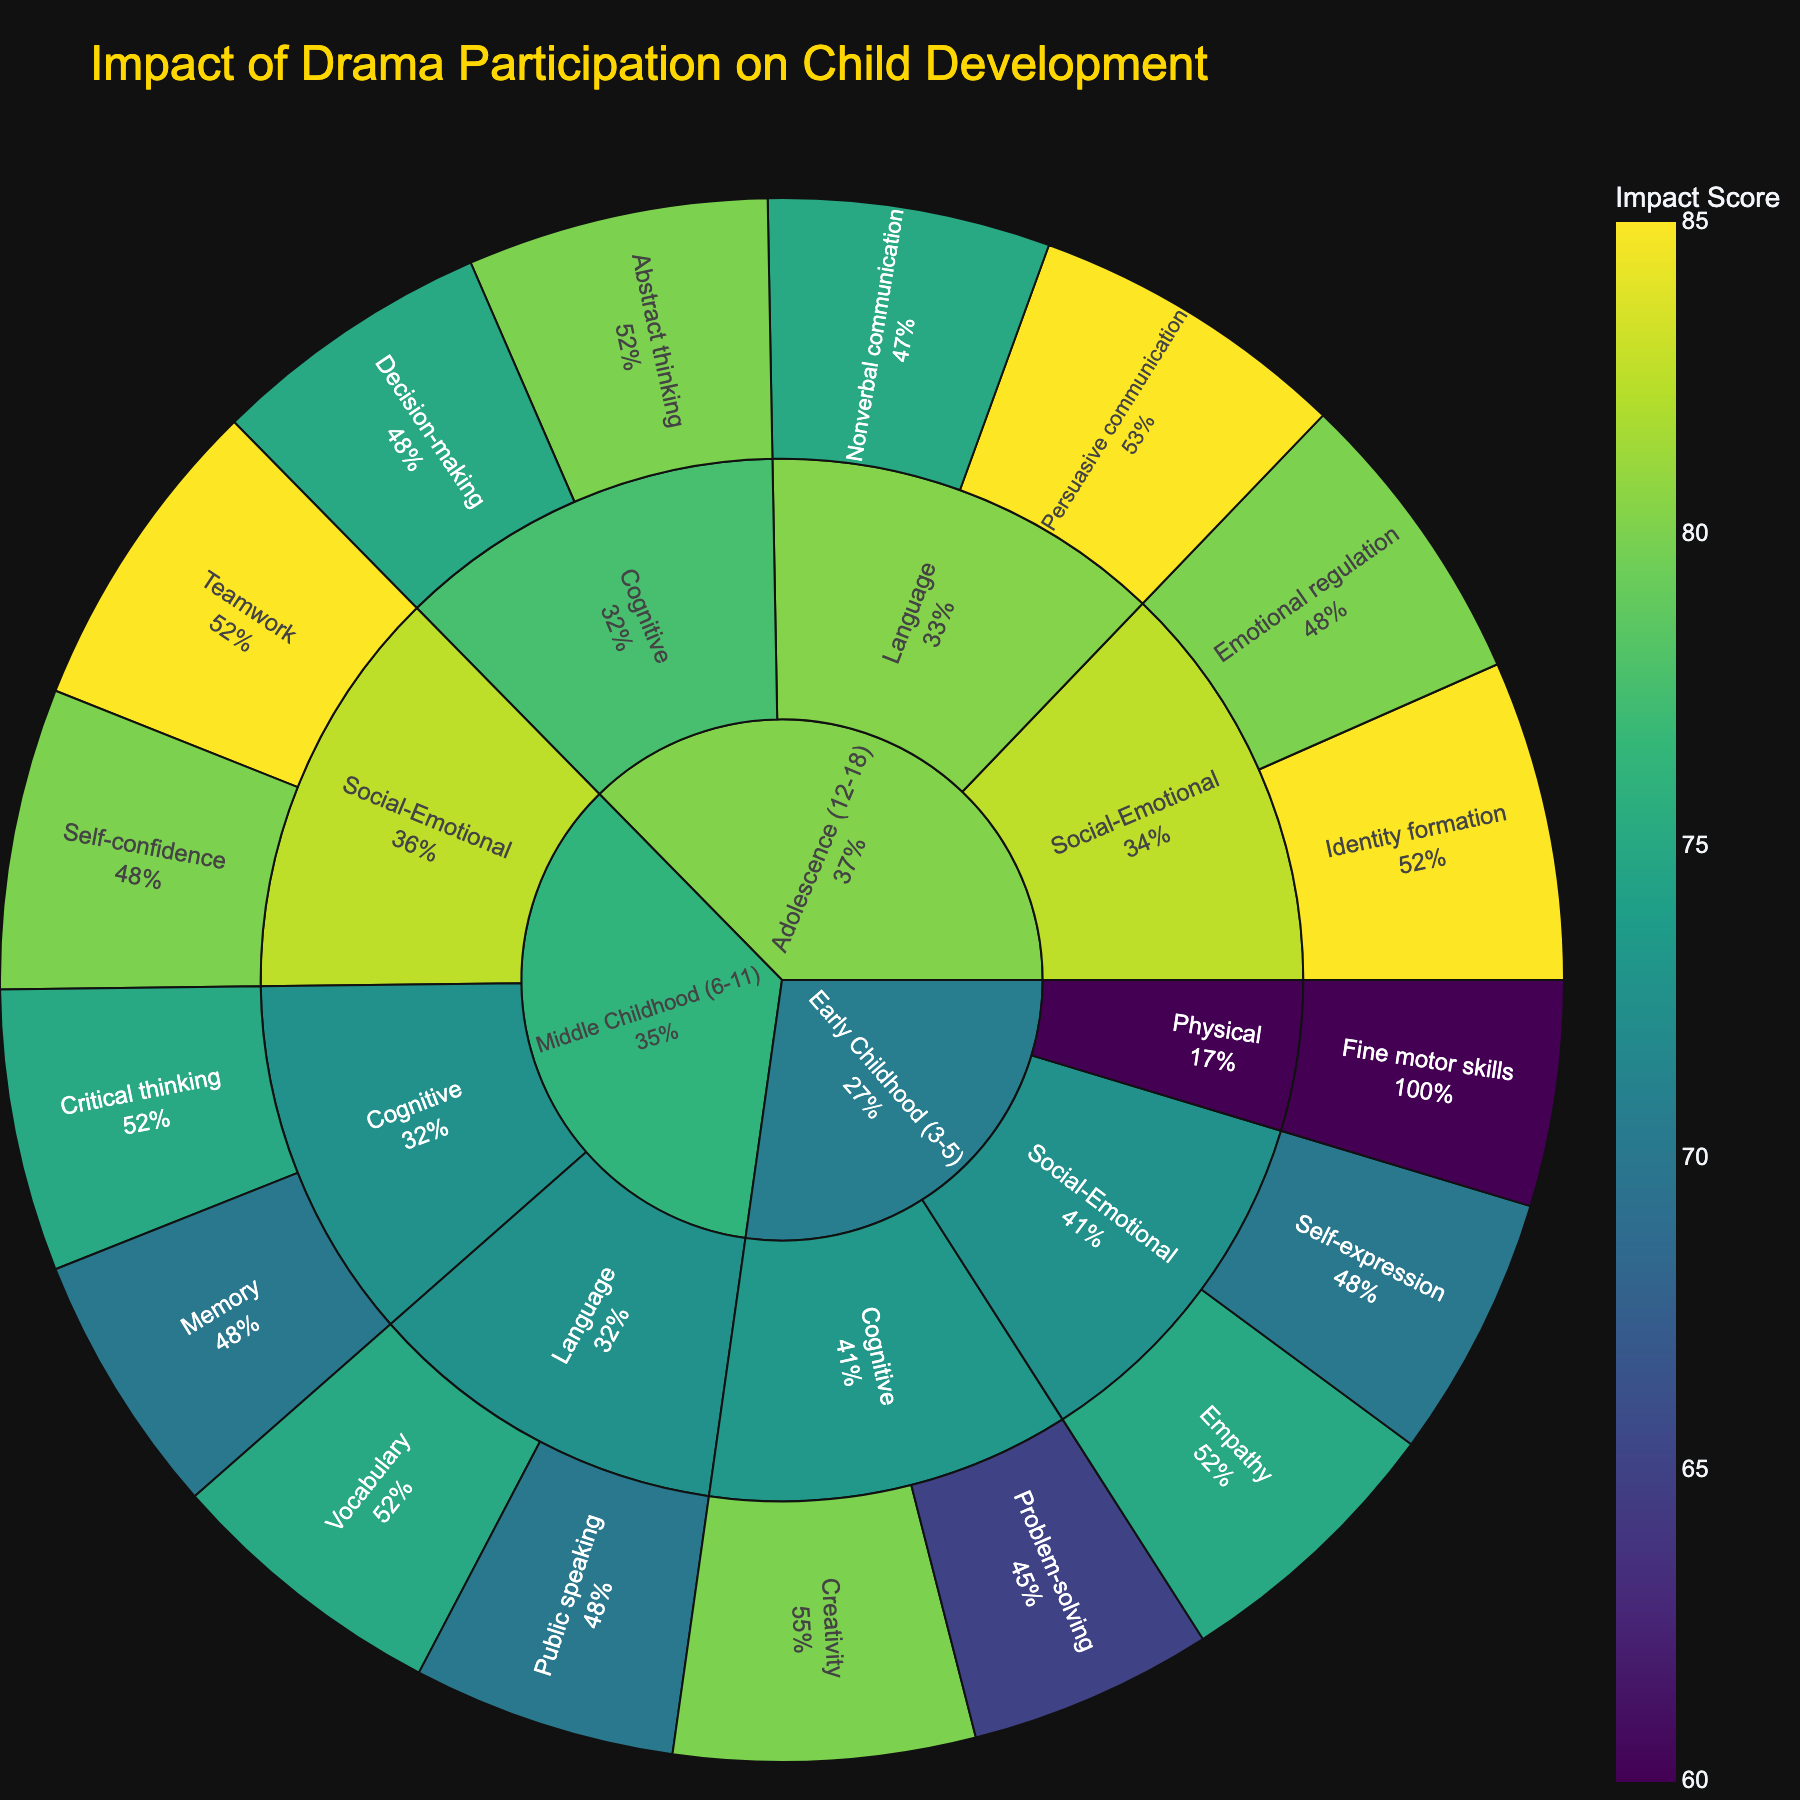What is the title of the figure? The title of the figure is displayed at the top. It summarizes the main focus of the visual representation.
Answer: Impact of Drama Participation on Child Development Which age group has the highest impact score for cognitive development? To determine this, look at the largest segment in terms of percentage for cognitive development within each age group.
Answer: Adolescence (12-18) Which specific skill in middle childhood has the highest impact score? Identify the specific skill under the 'Middle Childhood (6-11)' age group and then refer to the specific segments representing each skill's impact score to find the highest one.
Answer: Teamwork Compare the impact scores of creativity in early childhood and persuasive communication in adolescence. Which one is higher? Locate the segments for 'Creativity' under 'Early Childhood (3-5)' and 'Persuasive Communication' under 'Adolescence (12-18)' and compare their respective impact score values.
Answer: Persuasive communication Which developmental area in early childhood shows the lowest impact score? Focus on the 'Early Childhood (3-5)' segments, then identify the developmental area with the lowest score among its segments.
Answer: Physical What is the combined impact score for social-emotional development across all age groups? Locate the social-emotional segments in each age group, sum their impact scores: (75+70) + (85+80) + (85+80).
Answer: 475 Which specific skill has the highest impact score within the adolescence age group? Determine which segment under 'Adolescence (12-18)' has the largest value of impact score.
Answer: Identity formation In the middle childhood age group, how do the impact scores for cognitive development compare to those for language development? Compare the summed impact scores for cognitive (75+70) and language (75+70) development for middle childhood.
Answer: Equal Identify the developmental area with the most diverse set of specific skills in terms of impact scores. Evaluate each developmental area's specific skills across all age groups and consider the range of impact scores.
Answer: Social-Emotional What percentage of the impact score for self-expression in early childhood is compared to the total impact score for early childhood? Divide the impact score for self-expression (70) by the total impact score for early childhood ((65+80+75+70+60)=350) and multiply by 100.
Answer: 20% 